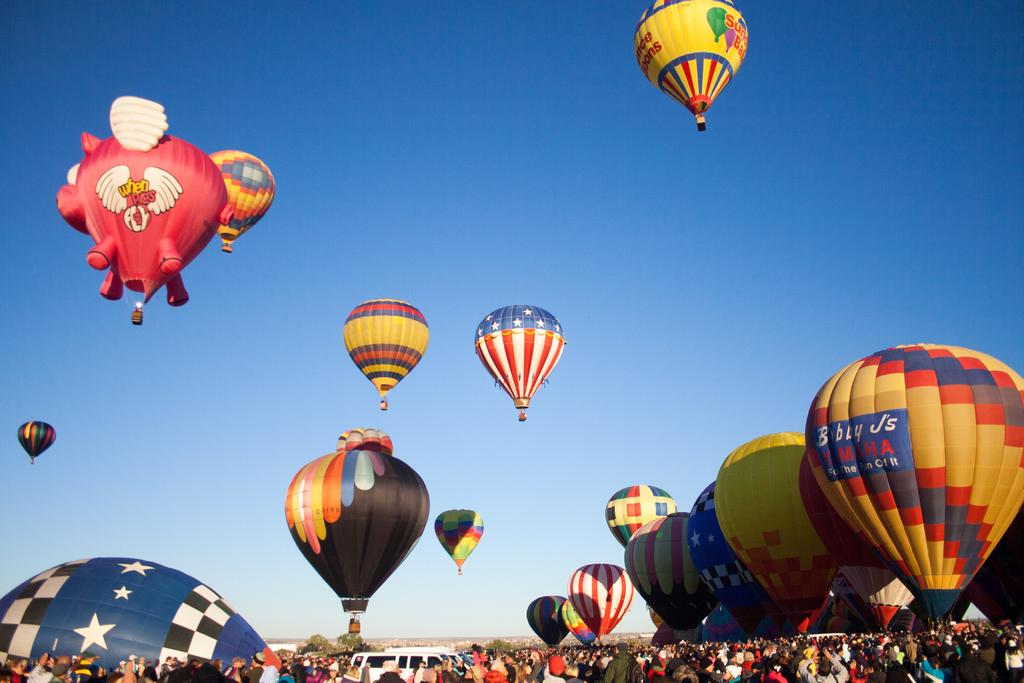How many subjects are present in the image? There are many people in the image. What else can be seen in the image besides people? There are vehicles in the image. Where are the people and vehicles located in the image? The people and vehicles are at the bottom side of the image. What other objects are present in the image? There are hot air balloons in the image. What part of the natural environment is visible in the image? The sky is visible in the image. What is the maid doing in the image? There is no maid present in the image. 